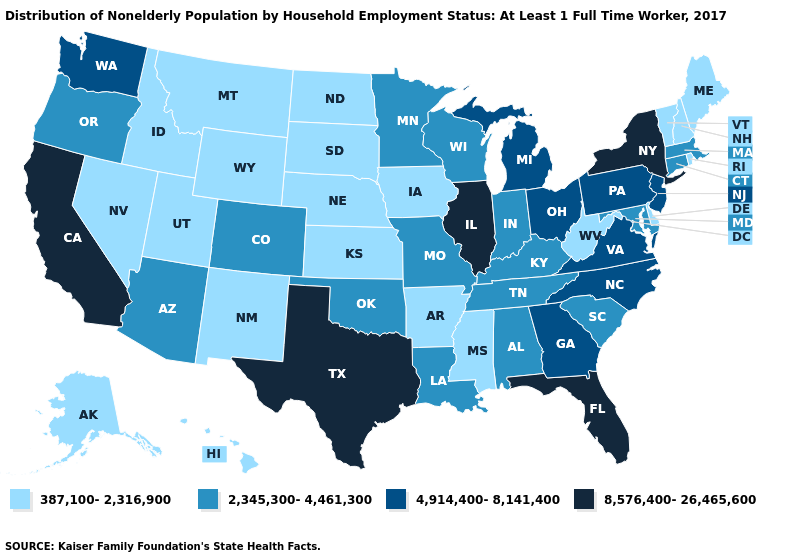Name the states that have a value in the range 387,100-2,316,900?
Quick response, please. Alaska, Arkansas, Delaware, Hawaii, Idaho, Iowa, Kansas, Maine, Mississippi, Montana, Nebraska, Nevada, New Hampshire, New Mexico, North Dakota, Rhode Island, South Dakota, Utah, Vermont, West Virginia, Wyoming. Name the states that have a value in the range 4,914,400-8,141,400?
Be succinct. Georgia, Michigan, New Jersey, North Carolina, Ohio, Pennsylvania, Virginia, Washington. Does Oklahoma have a higher value than New Hampshire?
Answer briefly. Yes. Does Alabama have the lowest value in the USA?
Be succinct. No. Which states hav the highest value in the South?
Write a very short answer. Florida, Texas. What is the value of Connecticut?
Short answer required. 2,345,300-4,461,300. Name the states that have a value in the range 4,914,400-8,141,400?
Concise answer only. Georgia, Michigan, New Jersey, North Carolina, Ohio, Pennsylvania, Virginia, Washington. Does California have a lower value than Illinois?
Quick response, please. No. How many symbols are there in the legend?
Be succinct. 4. Name the states that have a value in the range 8,576,400-26,465,600?
Quick response, please. California, Florida, Illinois, New York, Texas. Name the states that have a value in the range 8,576,400-26,465,600?
Answer briefly. California, Florida, Illinois, New York, Texas. Name the states that have a value in the range 2,345,300-4,461,300?
Short answer required. Alabama, Arizona, Colorado, Connecticut, Indiana, Kentucky, Louisiana, Maryland, Massachusetts, Minnesota, Missouri, Oklahoma, Oregon, South Carolina, Tennessee, Wisconsin. Name the states that have a value in the range 8,576,400-26,465,600?
Concise answer only. California, Florida, Illinois, New York, Texas. What is the highest value in states that border Montana?
Concise answer only. 387,100-2,316,900. Name the states that have a value in the range 387,100-2,316,900?
Keep it brief. Alaska, Arkansas, Delaware, Hawaii, Idaho, Iowa, Kansas, Maine, Mississippi, Montana, Nebraska, Nevada, New Hampshire, New Mexico, North Dakota, Rhode Island, South Dakota, Utah, Vermont, West Virginia, Wyoming. 